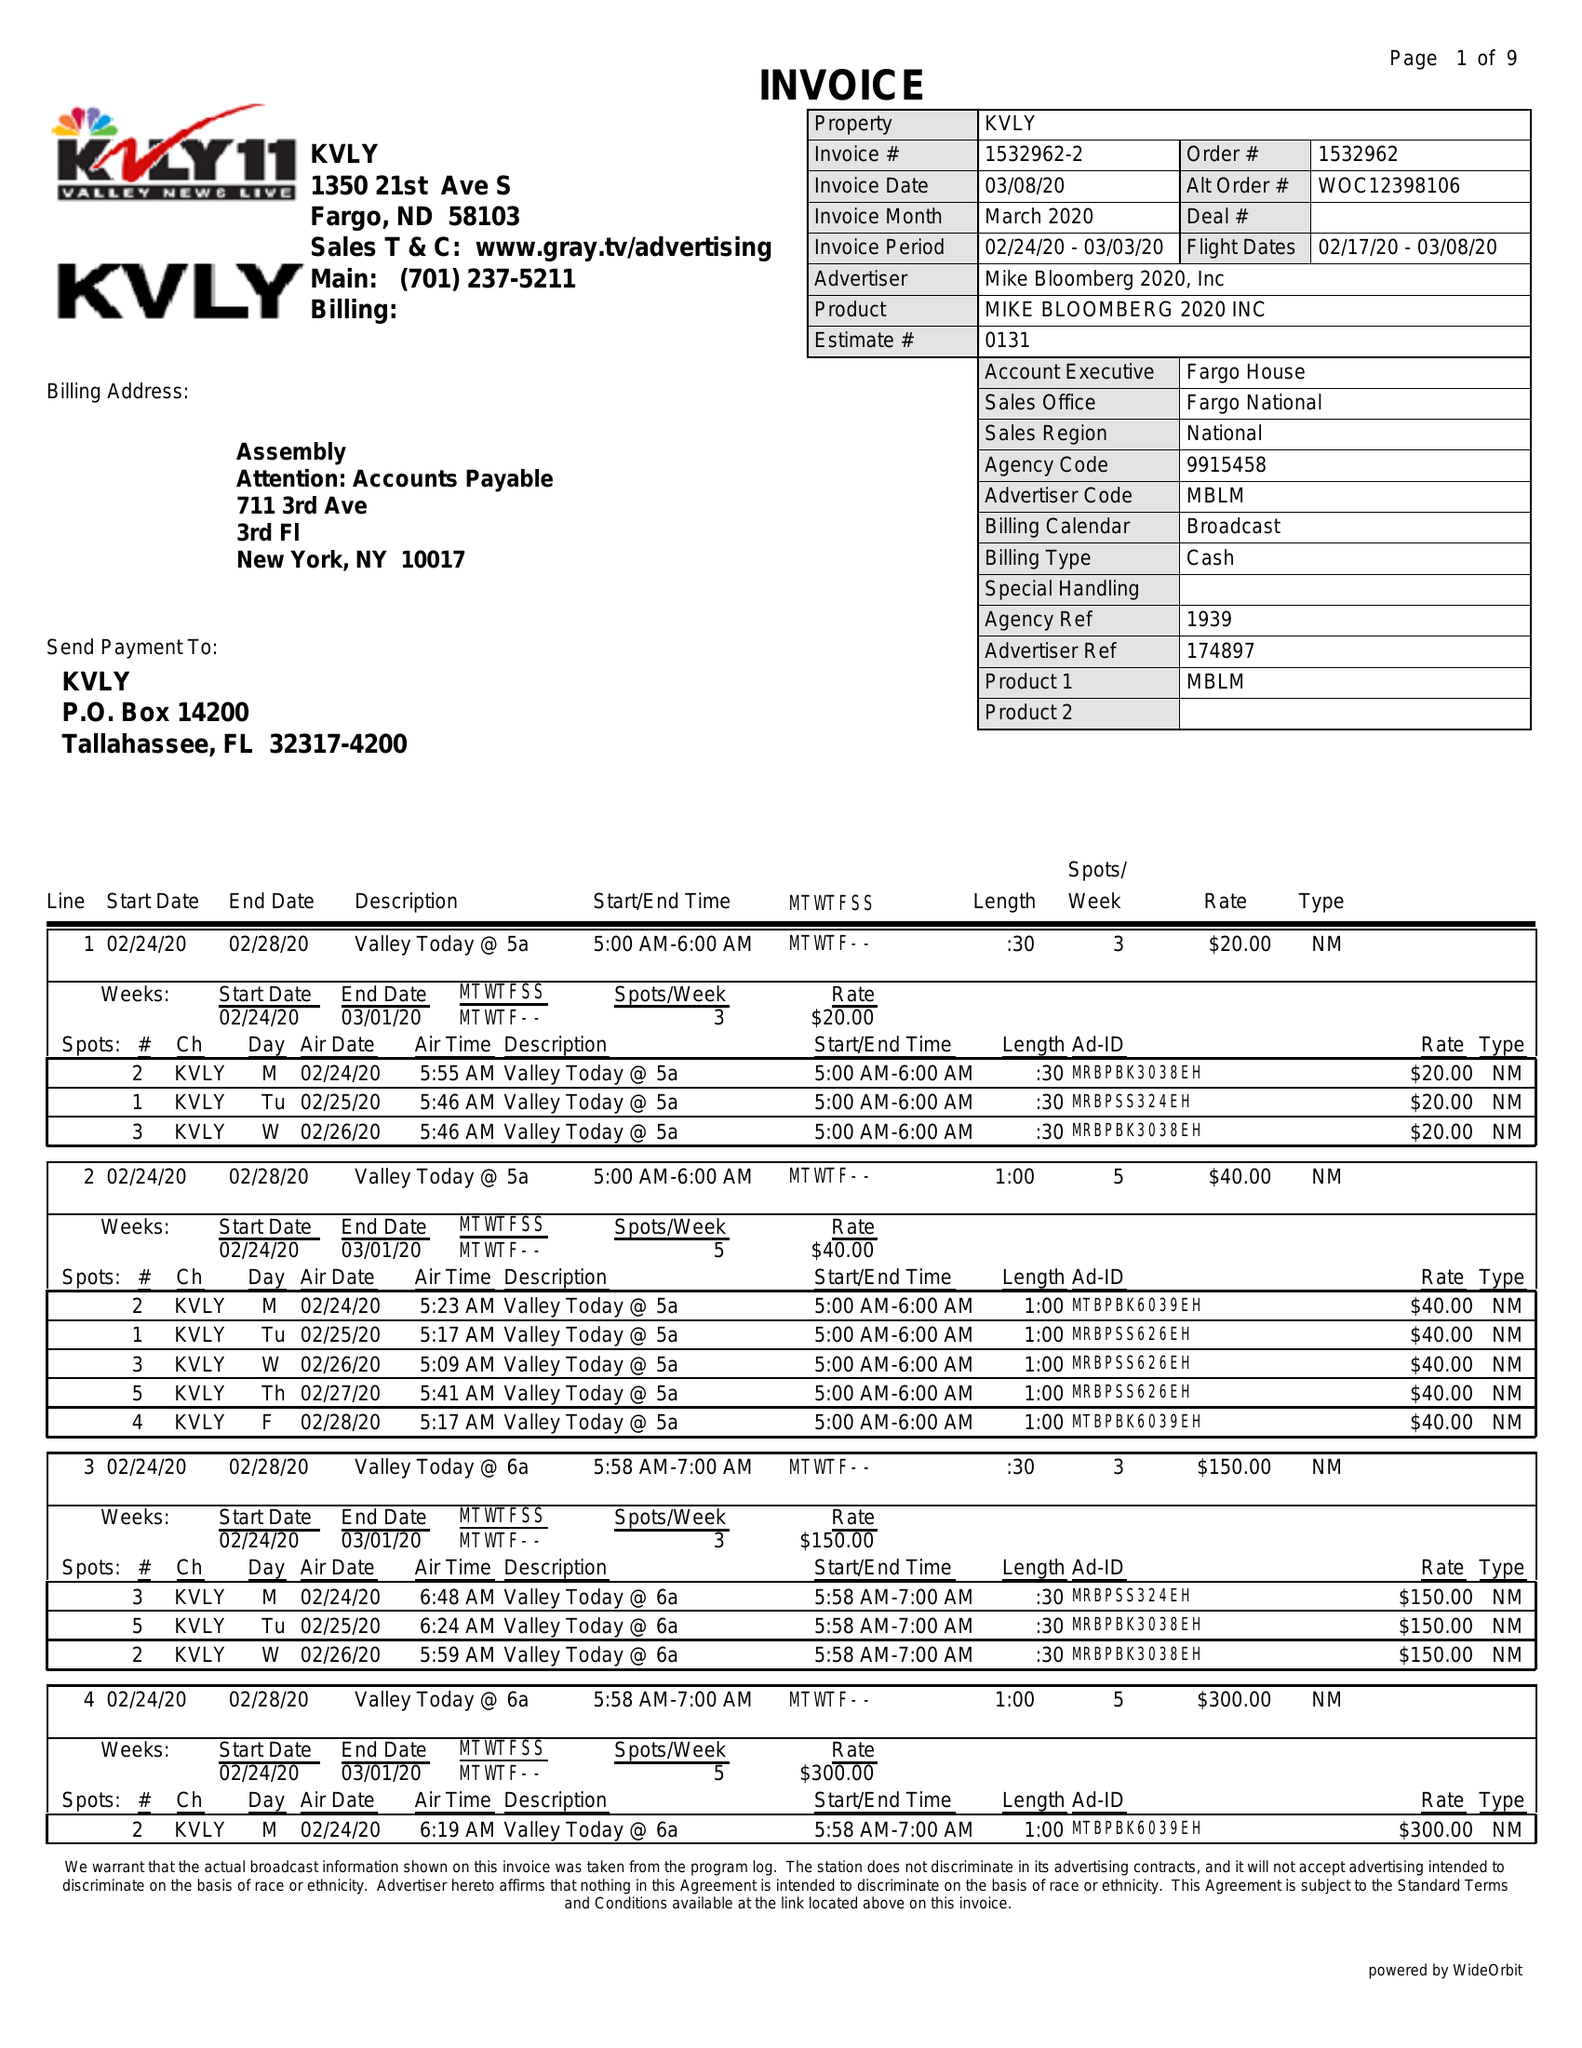What is the value for the contract_num?
Answer the question using a single word or phrase. 1532962 